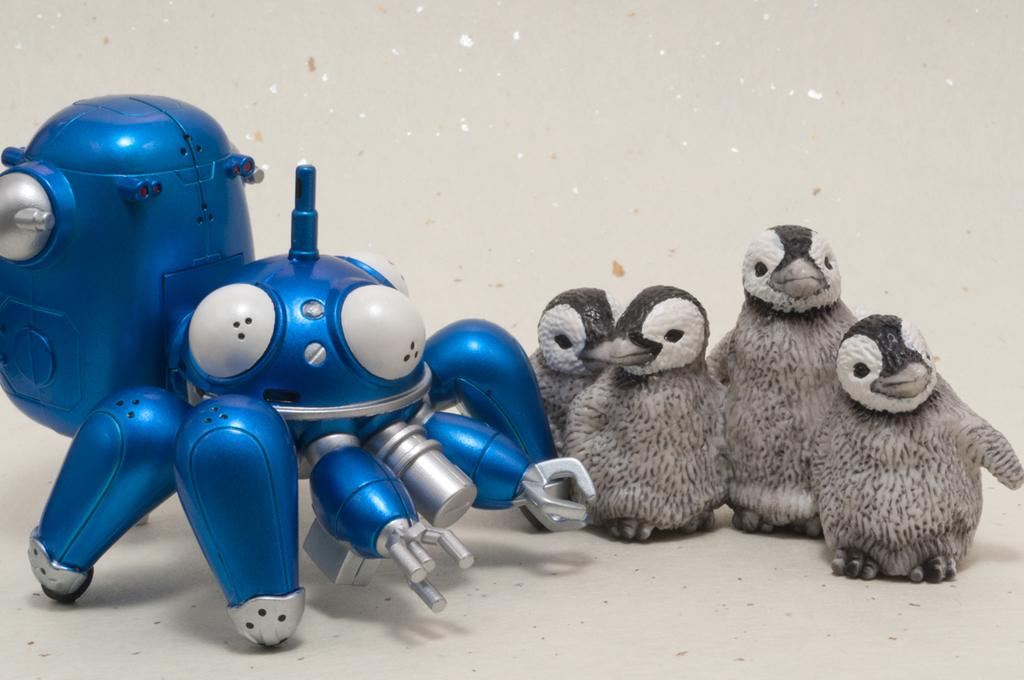What type of object is present in the image? There is a toy in the image. Can you describe the toy in more detail? There are toy penguins in the image. How many pieces of produce can be seen in the image? There is no produce present in the image; it features a toy penguin. Is the toy penguin wrapped in a parcel in the image? There is no parcel present in the image; it features a toy penguin. 